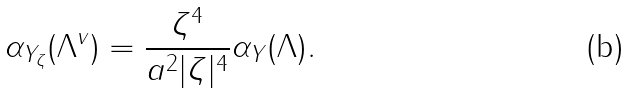<formula> <loc_0><loc_0><loc_500><loc_500>\alpha _ { Y _ { \zeta } } ( \Lambda ^ { v } ) = \frac { \zeta ^ { 4 } } { a ^ { 2 } | \zeta | ^ { 4 } } \alpha _ { Y } ( \Lambda ) .</formula> 